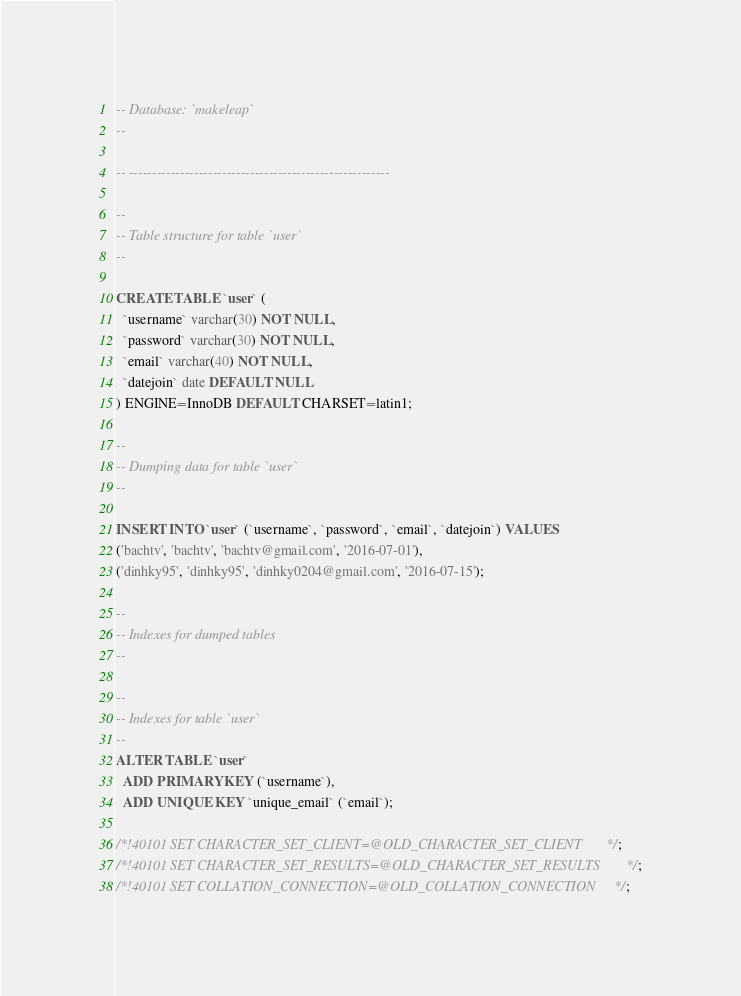<code> <loc_0><loc_0><loc_500><loc_500><_SQL_>-- Database: `makeleap`
--

-- --------------------------------------------------------

--
-- Table structure for table `user`
--

CREATE TABLE `user` (
  `username` varchar(30) NOT NULL,
  `password` varchar(30) NOT NULL,
  `email` varchar(40) NOT NULL,
  `datejoin` date DEFAULT NULL
) ENGINE=InnoDB DEFAULT CHARSET=latin1;

--
-- Dumping data for table `user`
--

INSERT INTO `user` (`username`, `password`, `email`, `datejoin`) VALUES
('bachtv', 'bachtv', 'bachtv@gmail.com', '2016-07-01'),
('dinhky95', 'dinhky95', 'dinhky0204@gmail.com', '2016-07-15');

--
-- Indexes for dumped tables
--

--
-- Indexes for table `user`
--
ALTER TABLE `user`
  ADD PRIMARY KEY (`username`),
  ADD UNIQUE KEY `unique_email` (`email`);

/*!40101 SET CHARACTER_SET_CLIENT=@OLD_CHARACTER_SET_CLIENT */;
/*!40101 SET CHARACTER_SET_RESULTS=@OLD_CHARACTER_SET_RESULTS */;
/*!40101 SET COLLATION_CONNECTION=@OLD_COLLATION_CONNECTION */;
</code> 